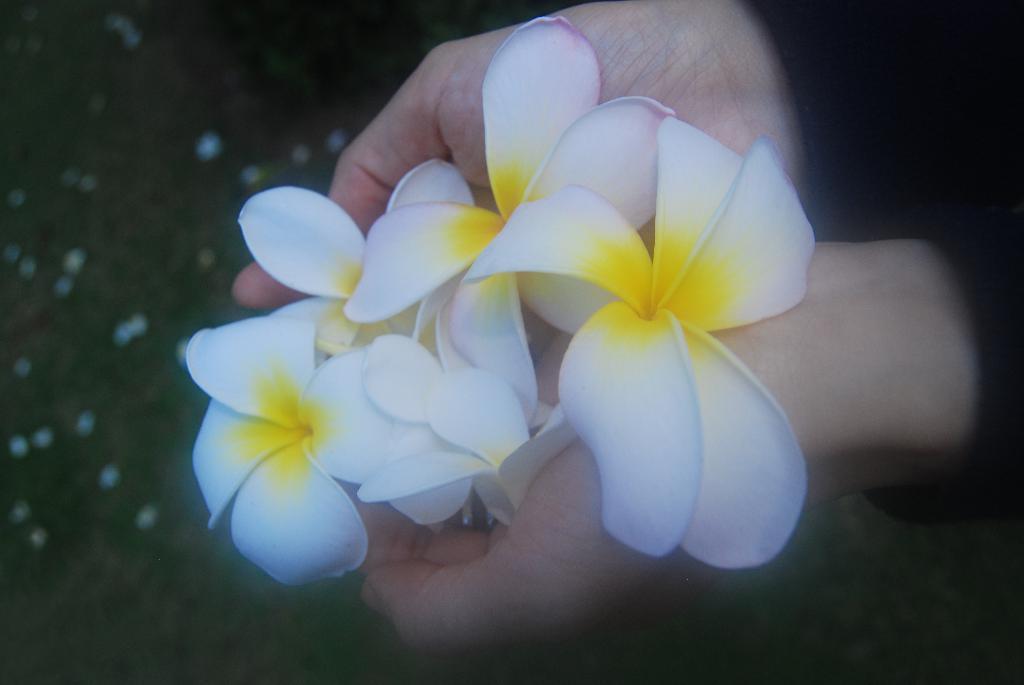Describe this image in one or two sentences. There is a person in black color dress, holding flowers which are in white and yellow color combination. In the background, there are other objects. 